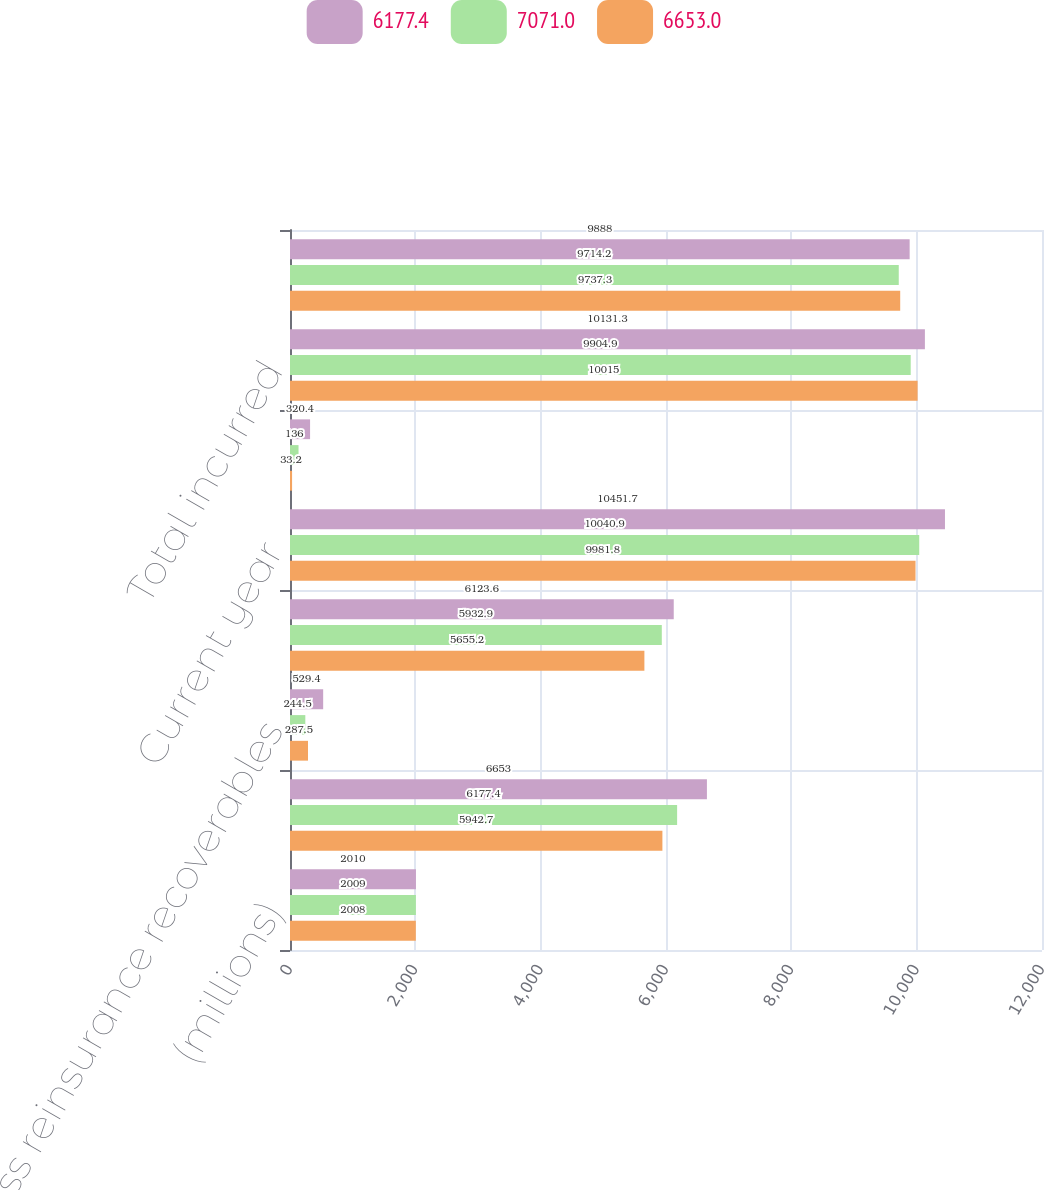<chart> <loc_0><loc_0><loc_500><loc_500><stacked_bar_chart><ecel><fcel>(millions)<fcel>Balance at January 1<fcel>Less reinsurance recoverables<fcel>Net balance at January 1<fcel>Current year<fcel>Prior years<fcel>Total incurred<fcel>Total paid<nl><fcel>6177.4<fcel>2010<fcel>6653<fcel>529.4<fcel>6123.6<fcel>10451.7<fcel>320.4<fcel>10131.3<fcel>9888<nl><fcel>7071<fcel>2009<fcel>6177.4<fcel>244.5<fcel>5932.9<fcel>10040.9<fcel>136<fcel>9904.9<fcel>9714.2<nl><fcel>6653<fcel>2008<fcel>5942.7<fcel>287.5<fcel>5655.2<fcel>9981.8<fcel>33.2<fcel>10015<fcel>9737.3<nl></chart> 